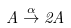<formula> <loc_0><loc_0><loc_500><loc_500>A \stackrel { \alpha } { \rightarrow } 2 A</formula> 